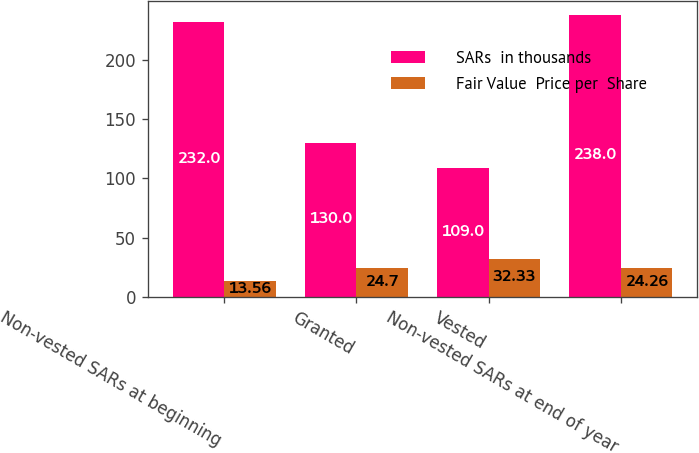Convert chart. <chart><loc_0><loc_0><loc_500><loc_500><stacked_bar_chart><ecel><fcel>Non-vested SARs at beginning<fcel>Granted<fcel>Vested<fcel>Non-vested SARs at end of year<nl><fcel>SARs  in thousands<fcel>232<fcel>130<fcel>109<fcel>238<nl><fcel>Fair Value  Price per  Share<fcel>13.56<fcel>24.7<fcel>32.33<fcel>24.26<nl></chart> 